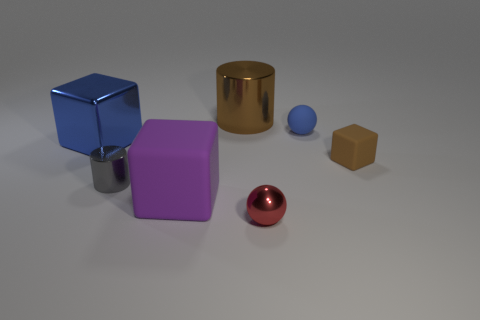There is a shiny cylinder that is behind the gray cylinder; is its color the same as the tiny cube?
Keep it short and to the point. Yes. Are there any blue blocks behind the tiny gray metallic thing?
Your response must be concise. Yes. What number of things are red spheres in front of the large blue metallic block or small brown cubes?
Make the answer very short. 2. What number of red objects are small things or tiny matte balls?
Your answer should be compact. 1. What number of other things are there of the same color as the tiny cube?
Offer a terse response. 1. Is the number of purple objects in front of the brown shiny thing less than the number of blue rubber objects?
Your response must be concise. No. There is a large cube that is to the right of the shiny cylinder in front of the brown thing that is in front of the brown metallic cylinder; what color is it?
Ensure brevity in your answer.  Purple. Are there any other things that are the same material as the purple cube?
Offer a terse response. Yes. What size is the other metallic thing that is the same shape as the gray metal thing?
Your answer should be very brief. Large. Is the number of tiny red metal balls to the left of the purple matte block less than the number of brown cylinders in front of the blue shiny block?
Offer a terse response. No. 